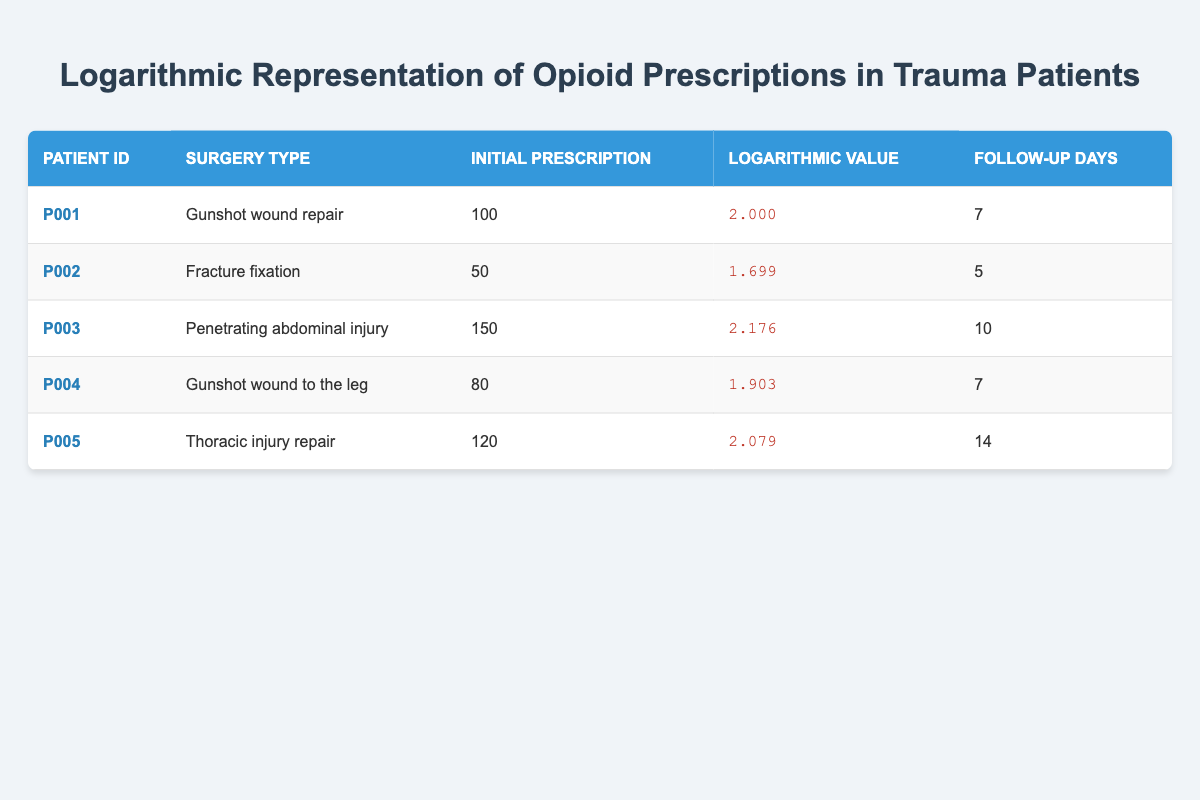What is the initial prescription for patient P002? In the table, we locate the row for patient P002. The initial prescription for this patient is listed under the "Initial Prescription" column, which shows the value as 50.
Answer: 50 What is the logarithmic value corresponding to the surgery type "Thoracic injury repair"? To find the logarithmic value for this surgery type, we look at the row for the patient with this surgery. The logarithmic value is listed under the "Logarithmic Value" column, which is given as 2.079.
Answer: 2.079 How many follow-up days did patient P005 have after surgery? We need to find patient P005's row and check the "Follow-up Days" column. There we see that patient P005 had 14 follow-up days after their surgery.
Answer: 14 What is the average initial prescription for all the patients listed? To find the average, we first sum the initial prescriptions: (100 + 50 + 150 + 80 + 120) = 500. Since there are 5 patients, we calculate the average as 500 / 5 = 100.
Answer: 100 Did any patient receive an initial prescription greater than 120? We check each patient's initial prescription. The initial prescriptions are 100, 50, 150, 80, and 120. We see that patient P003 received an initial prescription of 150, which is greater than 120, meaning the answer is yes.
Answer: Yes Which surgery type corresponds to the patient with the highest logarithmic value? We examine the "Logarithmic Value" column to find the highest value, which is 2.176 corresponding to patient P003. This patient's surgery type is "Penetrating abdominal injury."
Answer: Penetrating abdominal injury What is the difference in follow-up days between the patients with the highest and lowest initial prescriptions? The highest initial prescription is 150 (patient P003) with 10 follow-up days, and the lowest is 50 (patient P002) with 5 follow-up days. The difference is 10 - 5 = 5 follow-up days.
Answer: 5 How many patients had a logarithmic value less than 2? By checking the logarithmic values, we find that patient P002 with 1.699 and patient P004 with 1.903 are both less than 2. Thus, there are 2 patients with logarithmic values less than 2.
Answer: 2 What surgery type had the lowest initial prescription amount? We can identify the surgery type with the lowest initial prescription by checking the values. Patient P002, with a prescription of 50, had the lowest, and their surgery type is "Fracture fixation."
Answer: Fracture fixation 